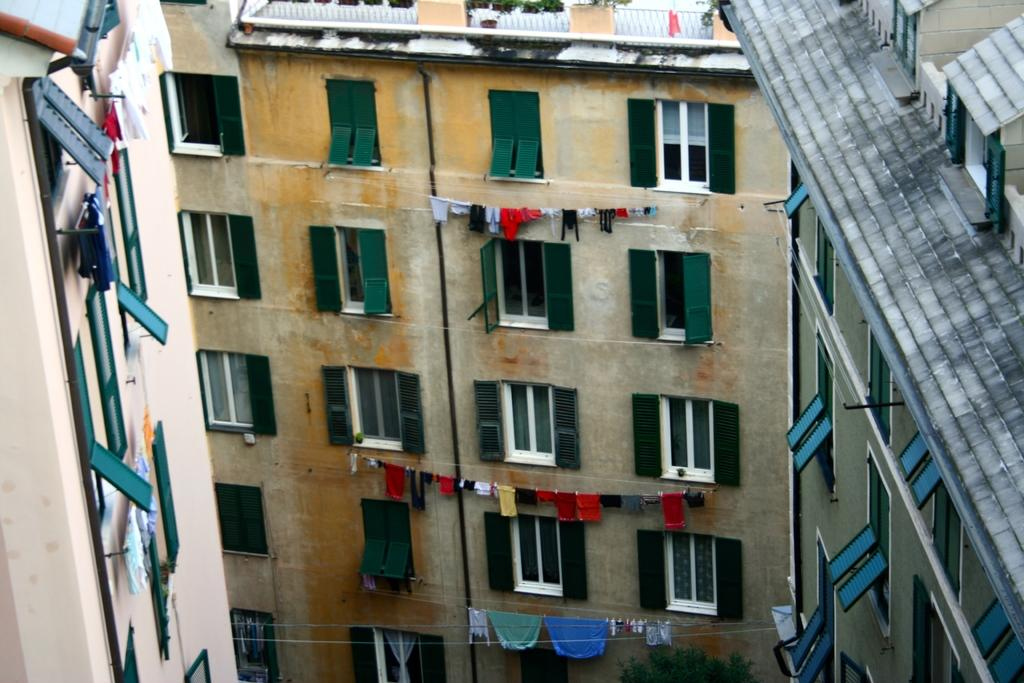What type of structures are visible in the image? There are buildings in the image. What feature do the buildings have? The buildings have windows. What else can be seen in the image besides the buildings? There are clothes hanging on ropes in the image. What type of cord is used to hang the clothes in the image? There is no mention of a cord in the image; the clothes are hanging on ropes. Can you tell me when the birth of the buildings occurred? The provided facts do not include information about the birth of the buildings, so it cannot be determined from the image. 